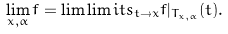<formula> <loc_0><loc_0><loc_500><loc_500>\lim _ { x , \alpha } f = \lim \lim i t s _ { t \to x } f | _ { T _ { x , \alpha } } ( t ) .</formula> 